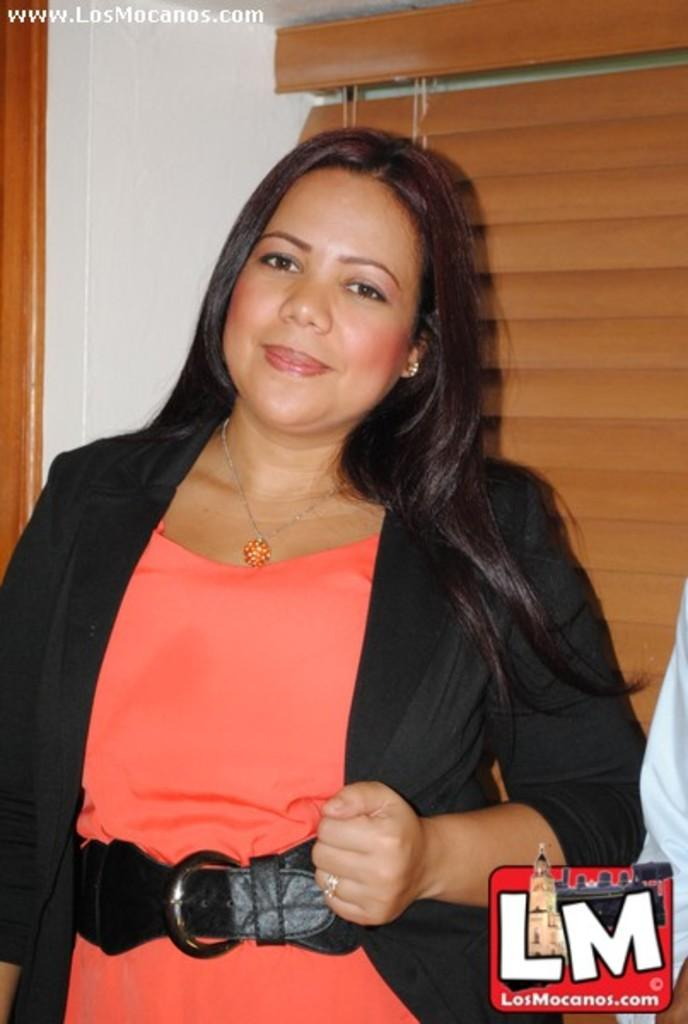What is present in the image that serves as a background? There is a wall in the image that serves as a background. Who is present in the image? There is a woman in the image. What is the woman wearing on her upper body? The woman is wearing a black jacket. What is the woman wearing on her lower body? The woman is wearing an orange dress. Can you see any crayons being used by the woman in the image? There are no crayons present in the image, and the woman is not using any. 